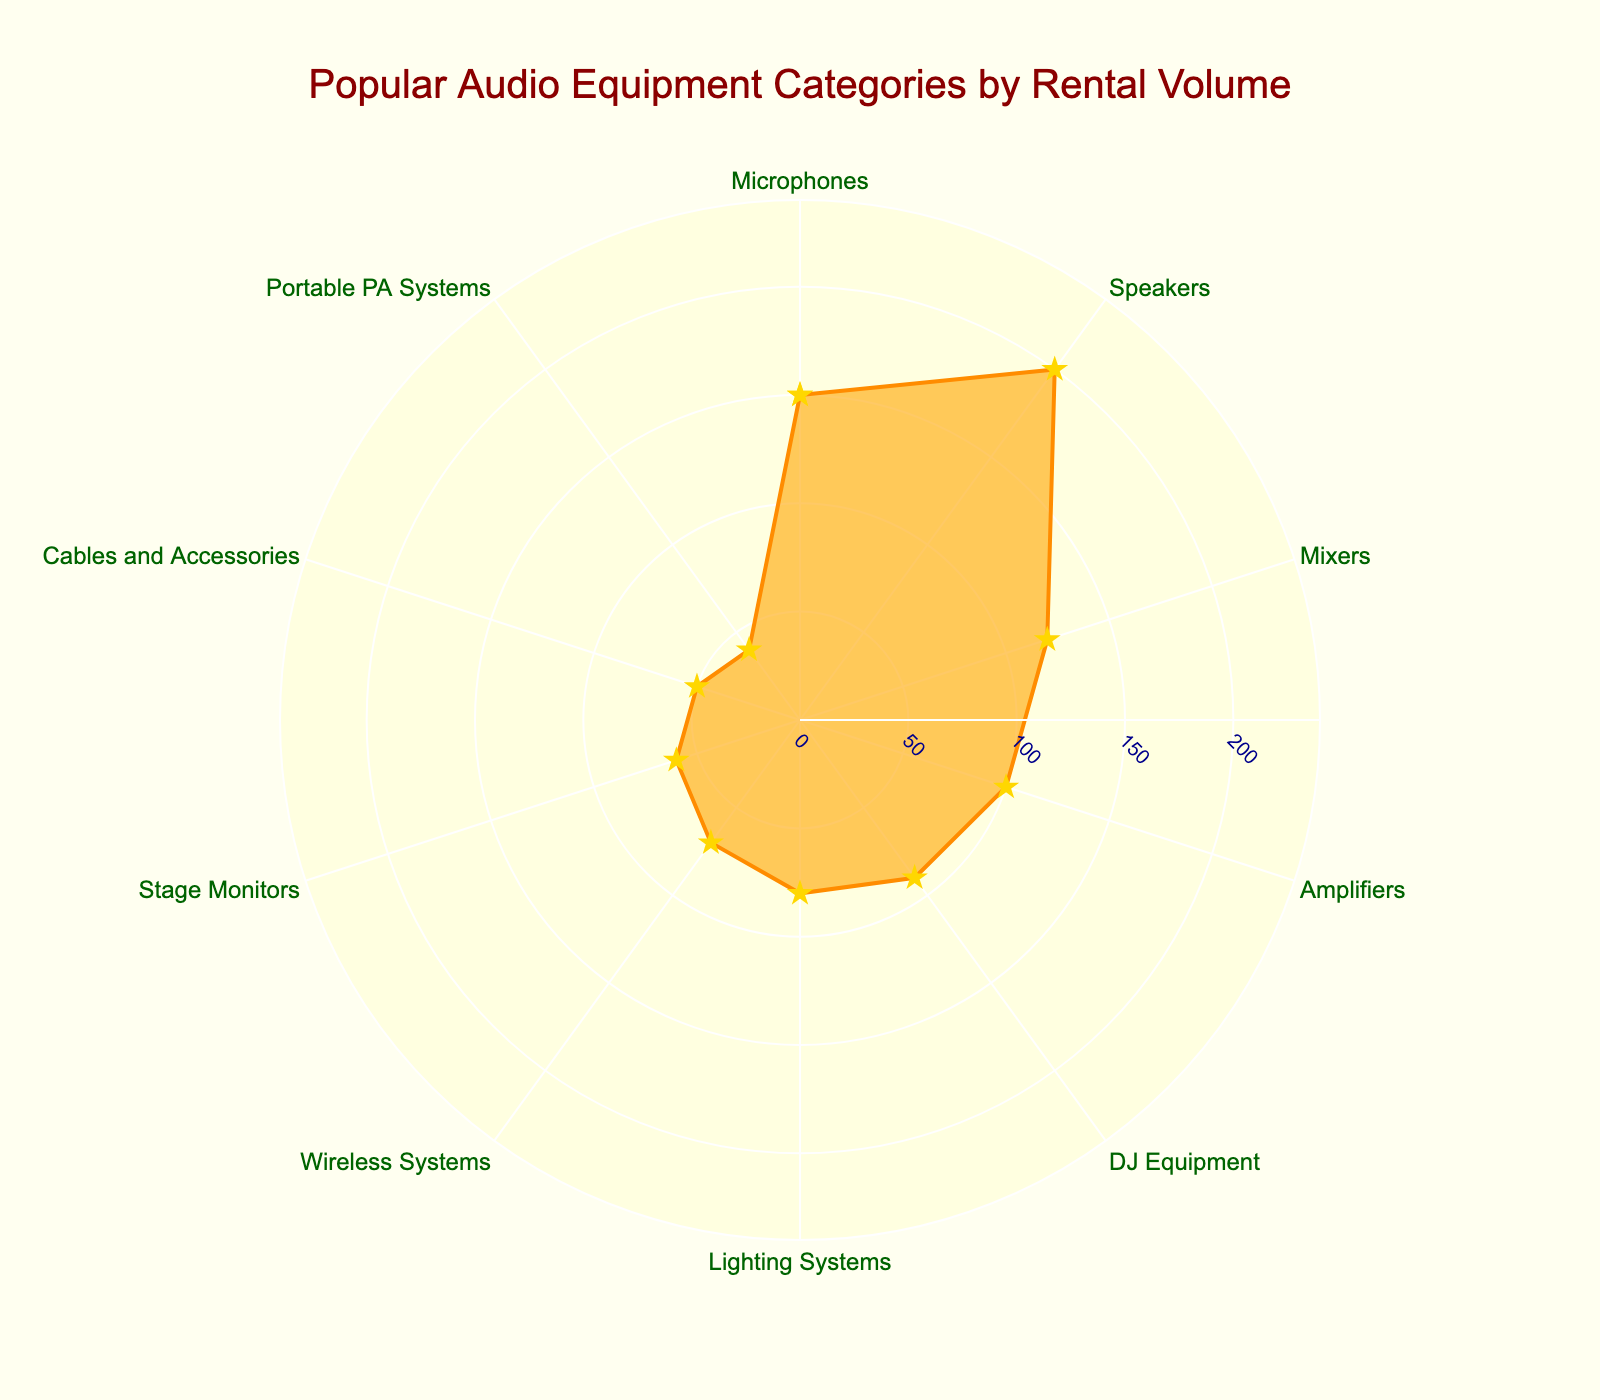What's the title of the chart? The title is usually the text displayed at the top of the chart. In this chart, look for the large text centered at the top.
Answer: Popular Audio Equipment Categories by Rental Volume How many categories are presented in the chart? Count the distinct sections or labels on the radial (polar) axis.
Answer: 10 Which audio equipment category has the highest rental volume? Identify the category with the largest radial distance from the center.
Answer: Speakers Which two categories have the lowest rental volumes? Look for the two shortest radial distances from the center, which represent the least rental volumes.
Answer: Portable PA Systems and Cables and Accessories What is the rental volume for DJ Equipment? Hover over the data point labeled "DJ Equipment" or look for the figure where this volume is displayed.
Answer: 90 How much more rental volume do Speakers have compared to Stage Monitors? Find the volumes for both categories (Speakers and Stage Monitors) and calculate the difference: 200 - 60.
Answer: 140 What is the sum of the rental volumes for Lighting Systems and Wireless Systems? Find the volumes for both categories (80 and 70) and add them together: 80 + 70.
Answer: 150 What is the average rental volume of all the categories? Sum all the rental volumes and divide by the number of categories: (150 + 200 + 120 + 100 + 90 + 80 + 70 + 60 + 50 + 40) / 10.
Answer: 96 Which category is exactly in the center of the chart when ordered by rental volume? List the categories by rental volume in ascending order and find the middle one.
Answer: Lighting Systems How is the filling color of the plot described? Identify the color used to fill the plot area within the enclosed shape.
Answer: rgba(255, 165, 0, 0.6) 